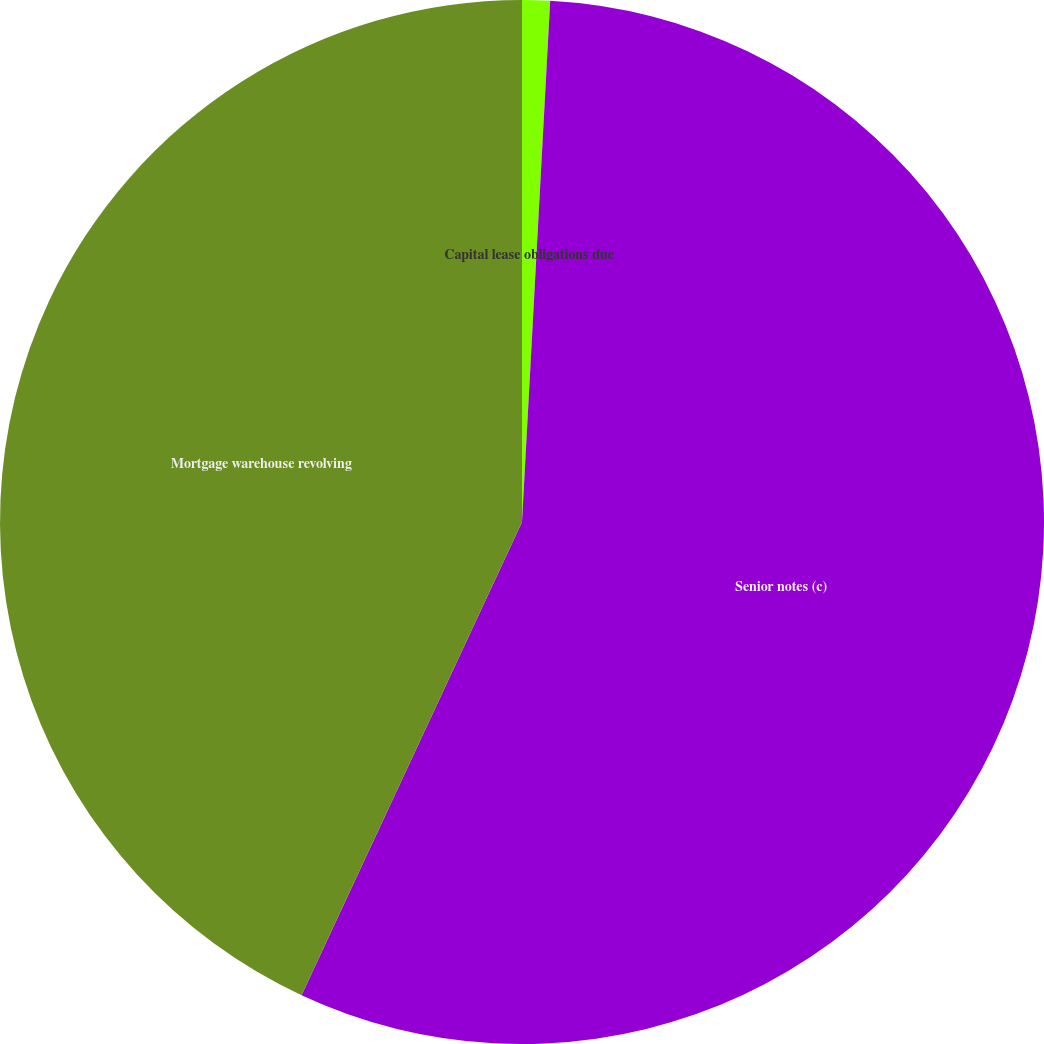<chart> <loc_0><loc_0><loc_500><loc_500><pie_chart><fcel>Capital lease obligations due<fcel>Senior notes (c)<fcel>Mortgage warehouse revolving<nl><fcel>0.86%<fcel>56.08%<fcel>43.06%<nl></chart> 